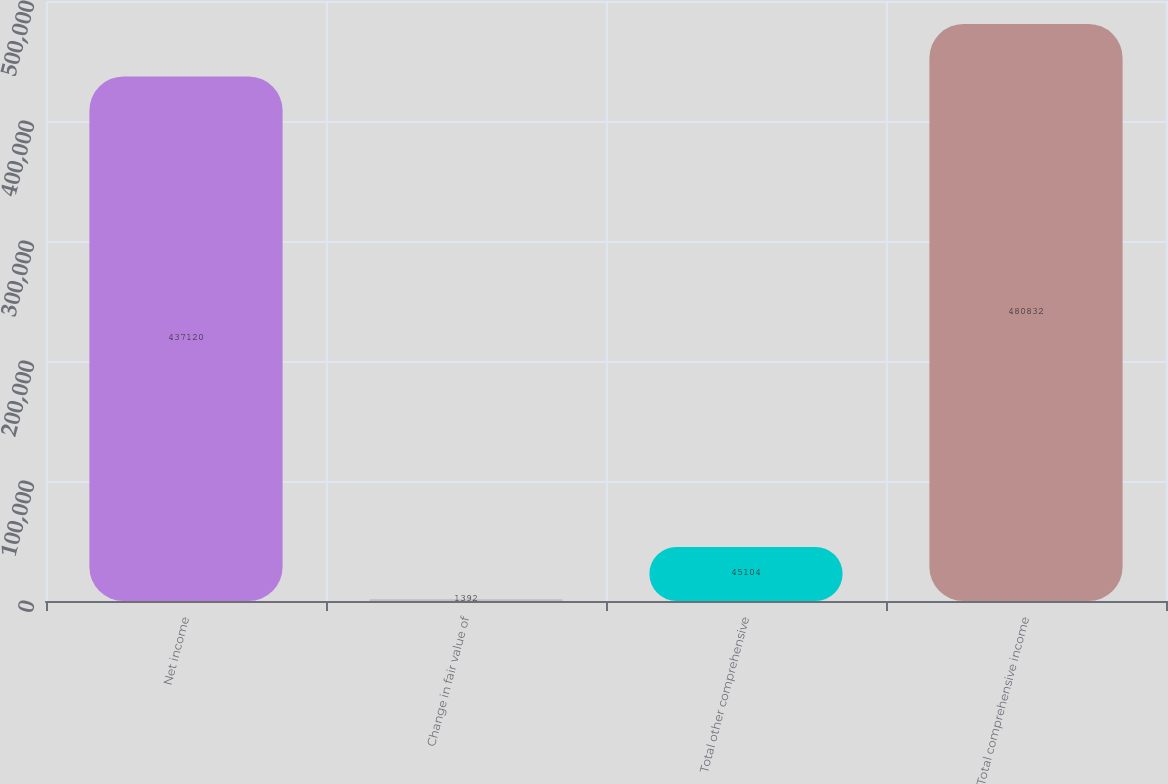Convert chart. <chart><loc_0><loc_0><loc_500><loc_500><bar_chart><fcel>Net income<fcel>Change in fair value of<fcel>Total other comprehensive<fcel>Total comprehensive income<nl><fcel>437120<fcel>1392<fcel>45104<fcel>480832<nl></chart> 